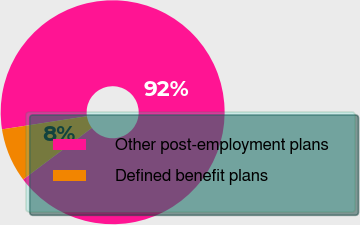Convert chart to OTSL. <chart><loc_0><loc_0><loc_500><loc_500><pie_chart><fcel>Other post-employment plans<fcel>Defined benefit plans<nl><fcel>92.2%<fcel>7.8%<nl></chart> 